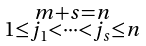<formula> <loc_0><loc_0><loc_500><loc_500>\begin{smallmatrix} m + s = n \\ 1 \leq j _ { 1 } < \dots < j _ { s } \leq n \end{smallmatrix}</formula> 